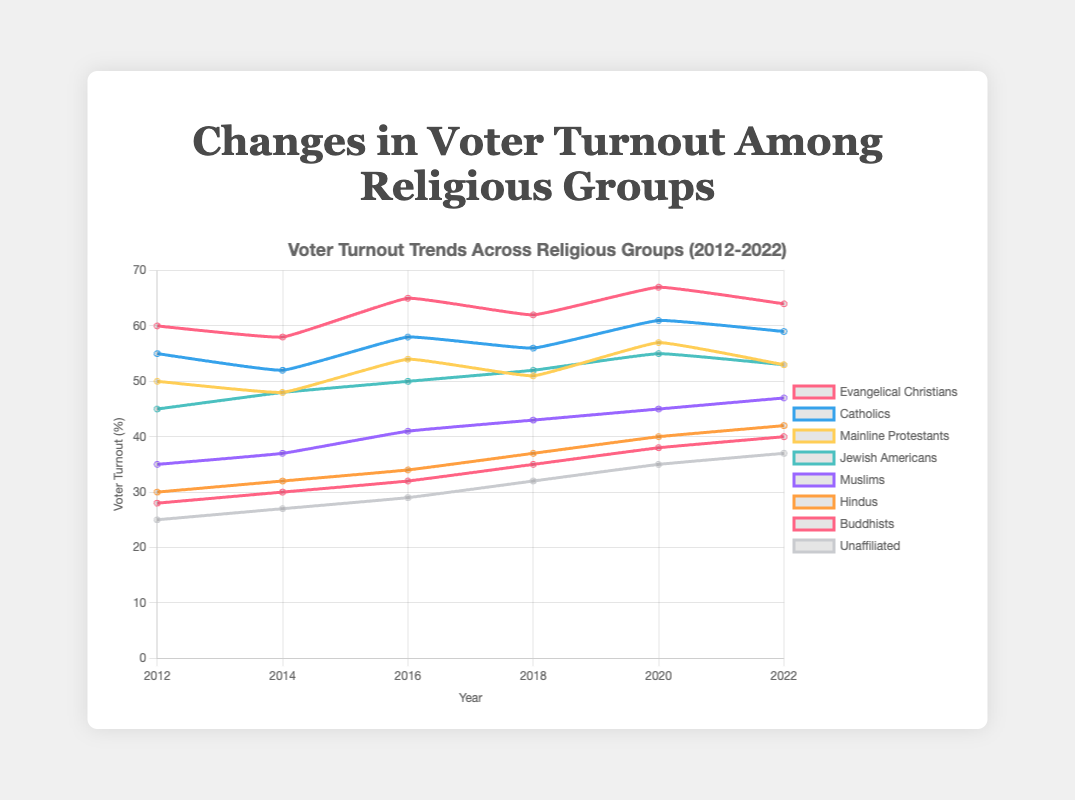Which religious group had the highest voter turnout in 2020? By looking at the line plot for the year 2020, we see that the line representing Evangelical Christians is the highest among all groups.
Answer: Evangelical Christians How did the voter turnout for Muslims change from 2012 to 2022? To find the change in voter turnout for Muslims, we subtract the 2012 value (35%) from the 2022 value (47%).
Answer: Increased by 12% Which group saw the largest increase in voter turnout between 2012 and 2022? By comparing the changes in voter turnout for each group, we see that Muslims increased from 35% to 47% (a 12% increase), which is the largest increase among all groups.
Answer: Muslims What was the average voter turnout for Catholics over the 10-year period? Sum the voter turnout percentages for Catholics (55, 52, 58, 56, 61, 59) and then divide by 6 (number of years). (55 + 52 + 58 + 56 + 61 + 59) / 6 = 341 / 6 ≈ 56.83
Answer: 56.83% Did any group consistently increase its voter turnout every election year? By examining the trends, Buddhists' voter turnout increased each year from 28% (2012) to 40% (2022) without any decreases.
Answer: Buddhists What was the difference in voter turnout between Evangelical Christians and Mainline Protestants in 2022? Subtract the voter turnout for Mainline Protestants (53%) from the voter turnout for Evangelical Christians (64%). 64 - 53 = 11
Answer: 11% Which group had the lowest voter turnout in 2012 and how much was it? By checking the values for 2012, the Unaffiliated group had the lowest voter turnout at 25%.
Answer: Unaffiliated, 25% How many groups had an increase in voter turnout from 2014 to 2018? By comparing the voter turnout in 2014 and 2018 for each group, we see Evangelical Christians, Catholics, Mainline Protestants, Jewish Americans, Muslims, Hindus, and Buddhists had increased turnout.
Answer: 7 groups Which two groups had identical voter turnout in 2022 and what was the turnout percentage? Jewish Americans and Mainline Protestants both had a voter turnout of 53% in 2022.
Answer: Jewish Americans and Mainline Protestants, 53% What is the combined voter turnout percentage for Hindus and Buddhists in 2022? Add the voter turnout percentages for Hindus (42%) and Buddhists (40%) in 2022. 42 + 40 = 82
Answer: 82% 